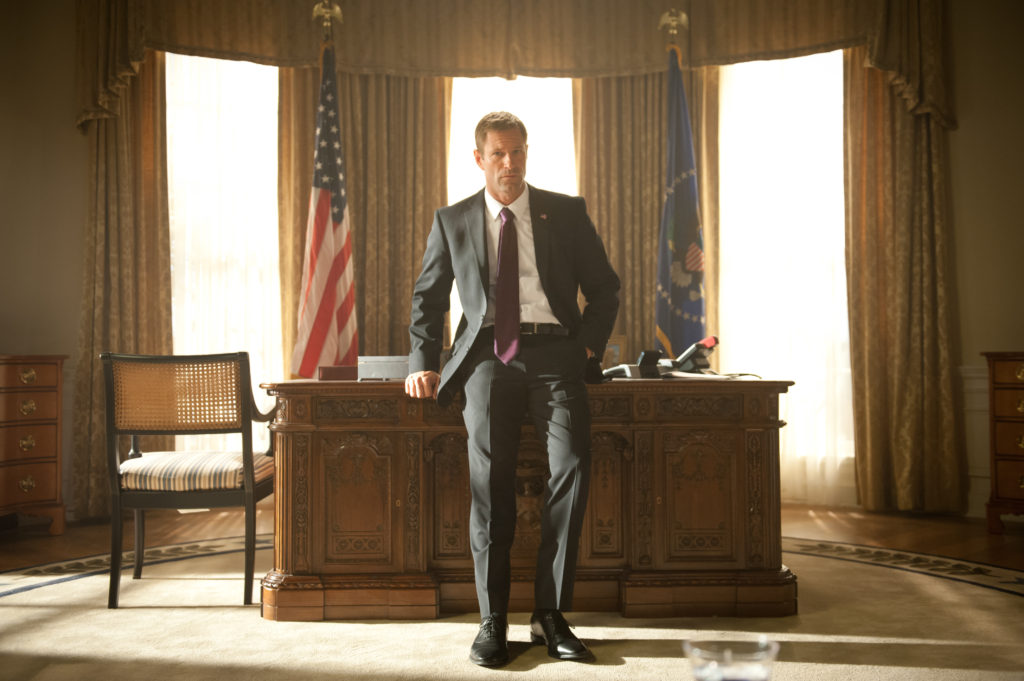Explain the visual content of the image in great detail. In this image, we see the actor known for playing President Benjamin Asher in the movie 'Olympus Has Fallen' standing confidently in front of a large, ornate wooden desk that resembles the one in the Oval Office. The room is spacious and bathed in natural light filtering through tall windows adorned with elegant drapes. Behind him, the American flag and another blue flag featuring a golden eagle are on display, reinforcing the presidential atmosphere. He is dressed in a sleek black suit, crisply pressed white shirt, and a purple tie, and exudes a commanding presence as he gazes thoughtfully into the distance. To the left of the image, there is a wooden chair with a cane seat and backrest, while the sunlight casts a warm glow across the room, highlighting the rich decor and stately ambiance. 